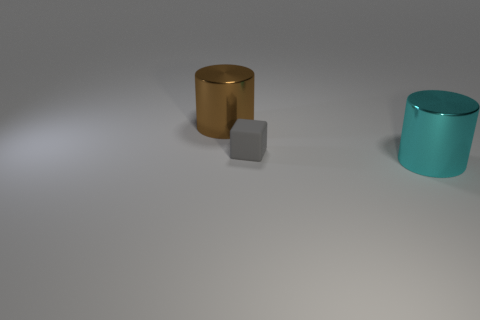Add 2 small purple rubber blocks. How many objects exist? 5 Subtract all cylinders. How many objects are left? 1 Subtract all large brown matte blocks. Subtract all metallic objects. How many objects are left? 1 Add 2 cylinders. How many cylinders are left? 4 Add 3 tiny blue matte cylinders. How many tiny blue matte cylinders exist? 3 Subtract 0 cyan spheres. How many objects are left? 3 